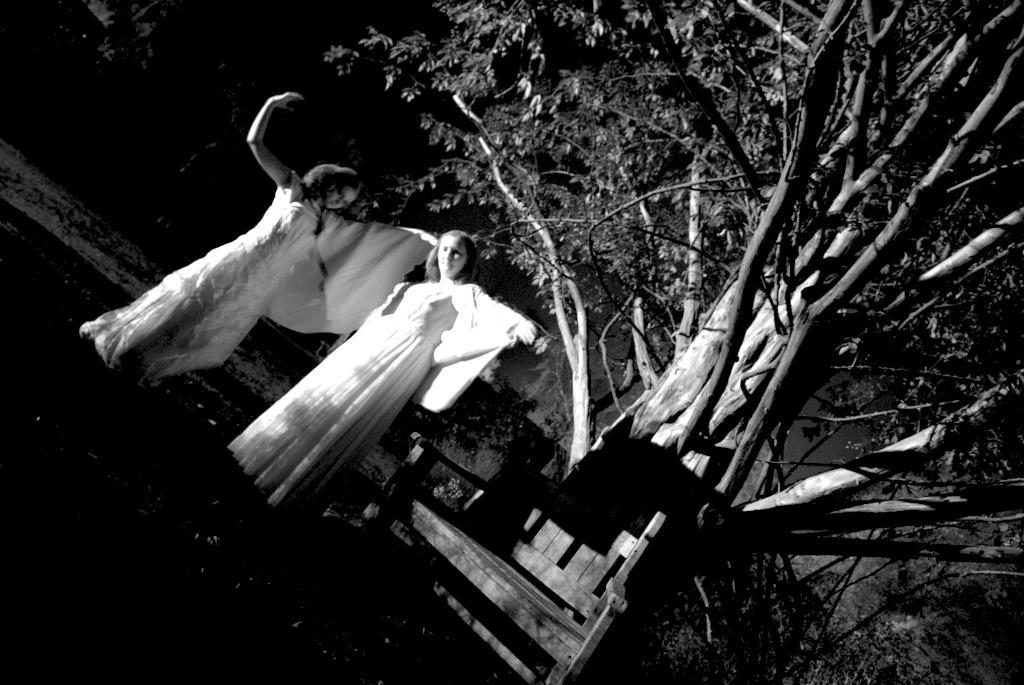How many people are in the image? There are two ladies in the image. What are the ladies wearing? The ladies are wearing white gowns. What can be seen in the image besides the ladies? There is a bench in the image. What is visible in the background of the image? There are trees in the background of the image. Can you tell me the sum of the numbers on the ladies' gowns? There are no numbers present on the ladies' gowns, so it is not possible to perform an addition. 